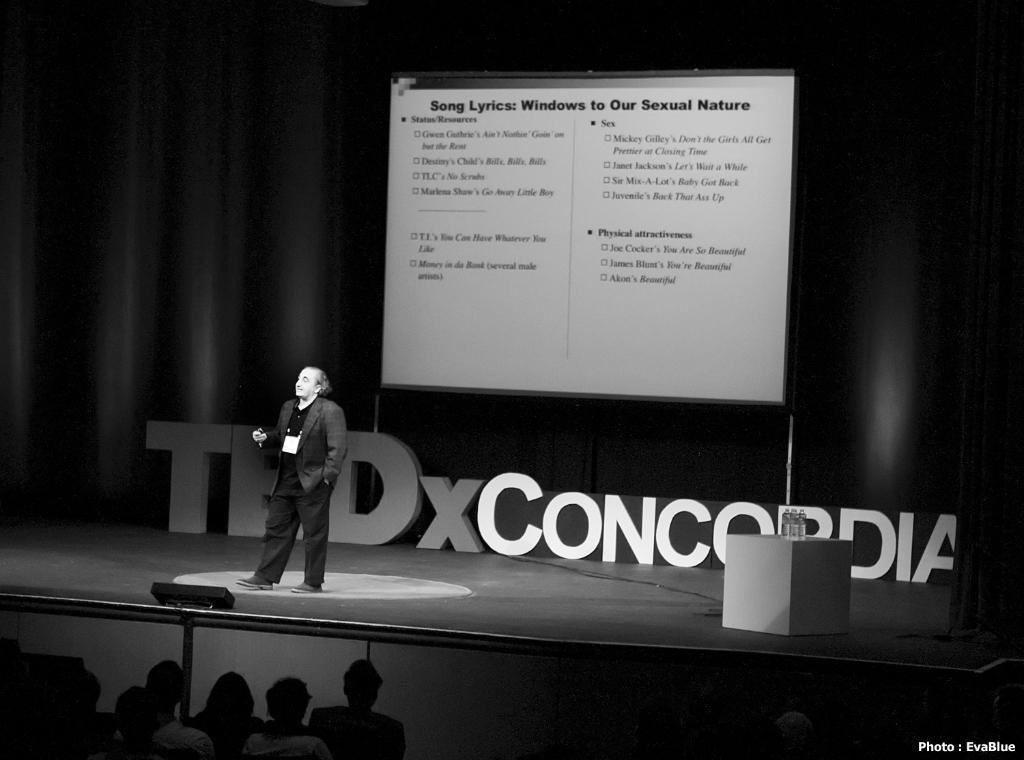Describe this image in one or two sentences. In this image there is a person on the stage, there is a display with some text, an object on the box, a poster with a name and a curtain are on the stage, in front of the stage there are few people. 